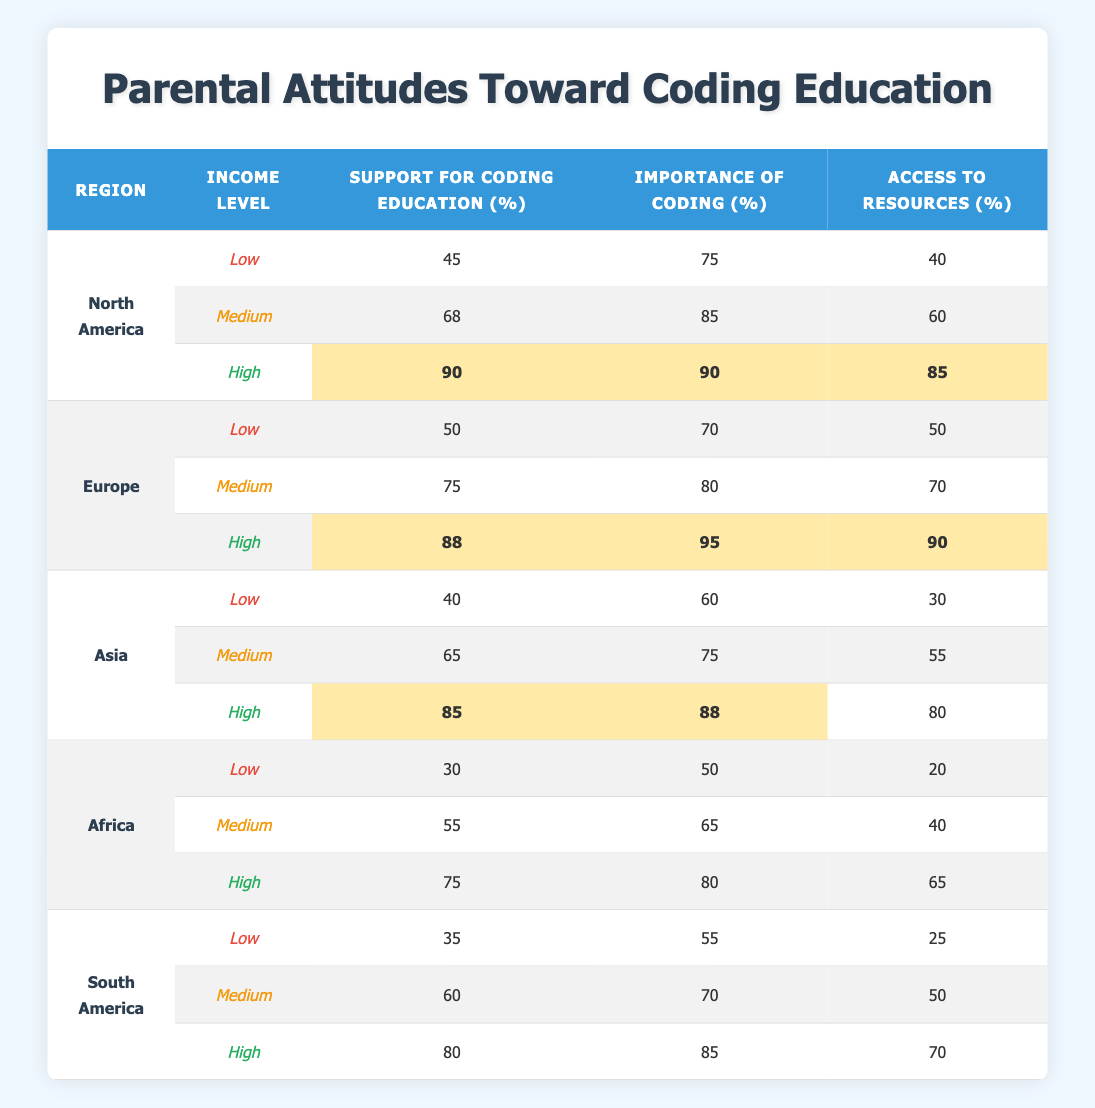What is the support for coding education among high-income families in Europe? From the table, we look under the Europe section for the high-income level, where the support for coding education is listed as 88%.
Answer: 88% Which region has the highest support for coding education among low-income families? In the table, we check the support for coding education for all regions under the low-income category. North America has 45%, Europe has 50%, Asia has 40%, Africa has 30%, and South America has 35%. The highest value is 50% from Europe.
Answer: Europe What is the average importance of coding for medium-income families across all regions? We first sum the importance of coding for medium-income families from each region: North America (85) + Europe (80) + Asia (75) + Africa (65) + South America (70) = 375. Then we divide by the number of regions (5): 375/5 = 75.
Answer: 75 Is the access to resources for high-income families higher in North America than in Africa? In the table, for North America at high-income level, access to resources is 85%. For Africa, it is 65%. Since 85 is greater than 65, the statement is true.
Answer: Yes Which region shows the largest difference in support for coding education between low and high-income families? We find the support for coding education across income levels for each region: North America (45 to 90) has a difference of 45, Europe (50 to 88) has a difference of 38, Asia (40 to 85) has a difference of 45, Africa (30 to 75) has a difference of 45, and South America (35 to 80) has a difference of 45. All differences from low to high in these regions are equal, but North America has the largest absolute value of support at both levels.
Answer: North America What two income levels in Asia have the same importance of coding? Looking at the table, for low-income families in Asia, the importance of coding is 60, and for medium-income families, it is 75. The high-income families have an importance of coding at 88%. Since no two values match in importance for Asia, the answer is there are none.
Answer: None 